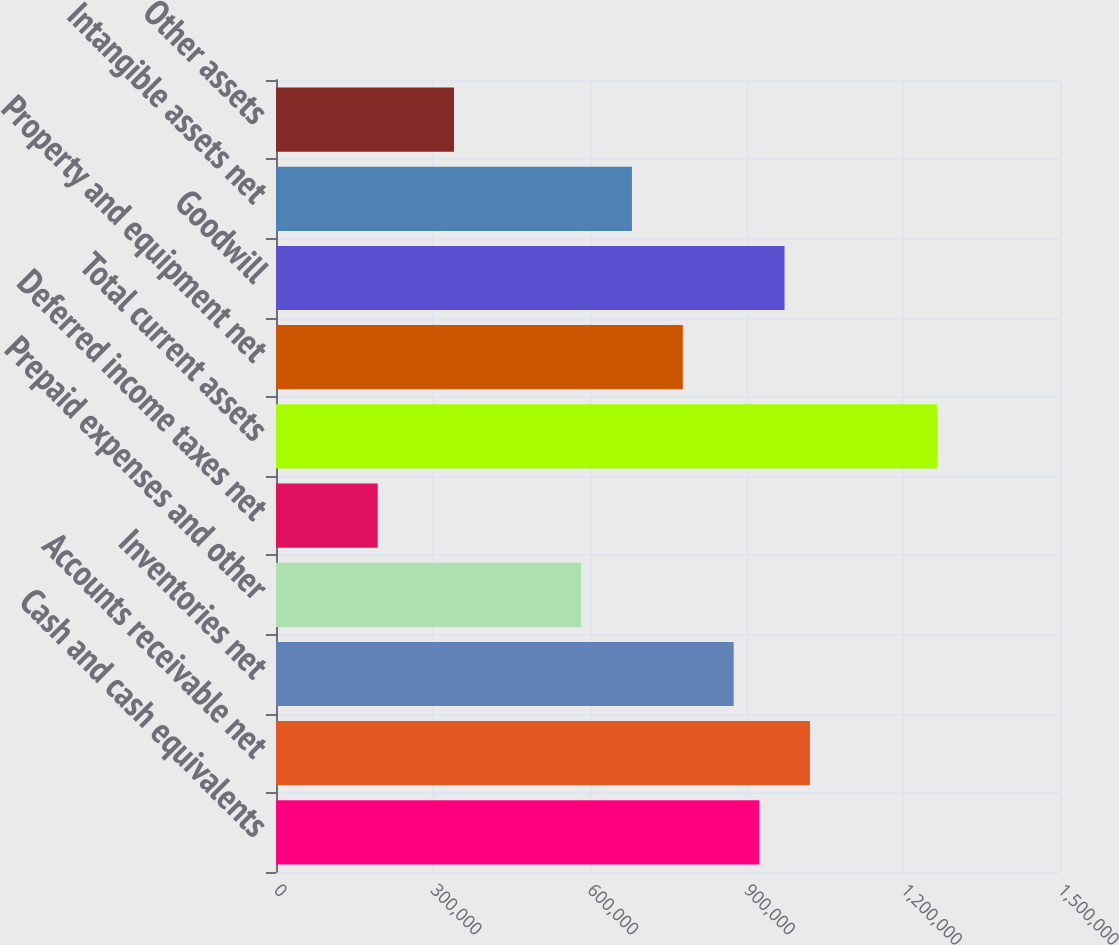<chart> <loc_0><loc_0><loc_500><loc_500><bar_chart><fcel>Cash and cash equivalents<fcel>Accounts receivable net<fcel>Inventories net<fcel>Prepaid expenses and other<fcel>Deferred income taxes net<fcel>Total current assets<fcel>Property and equipment net<fcel>Goodwill<fcel>Intangible assets net<fcel>Other assets<nl><fcel>924287<fcel>1.02158e+06<fcel>875640<fcel>583763<fcel>194592<fcel>1.26481e+06<fcel>778348<fcel>972933<fcel>681055<fcel>340531<nl></chart> 